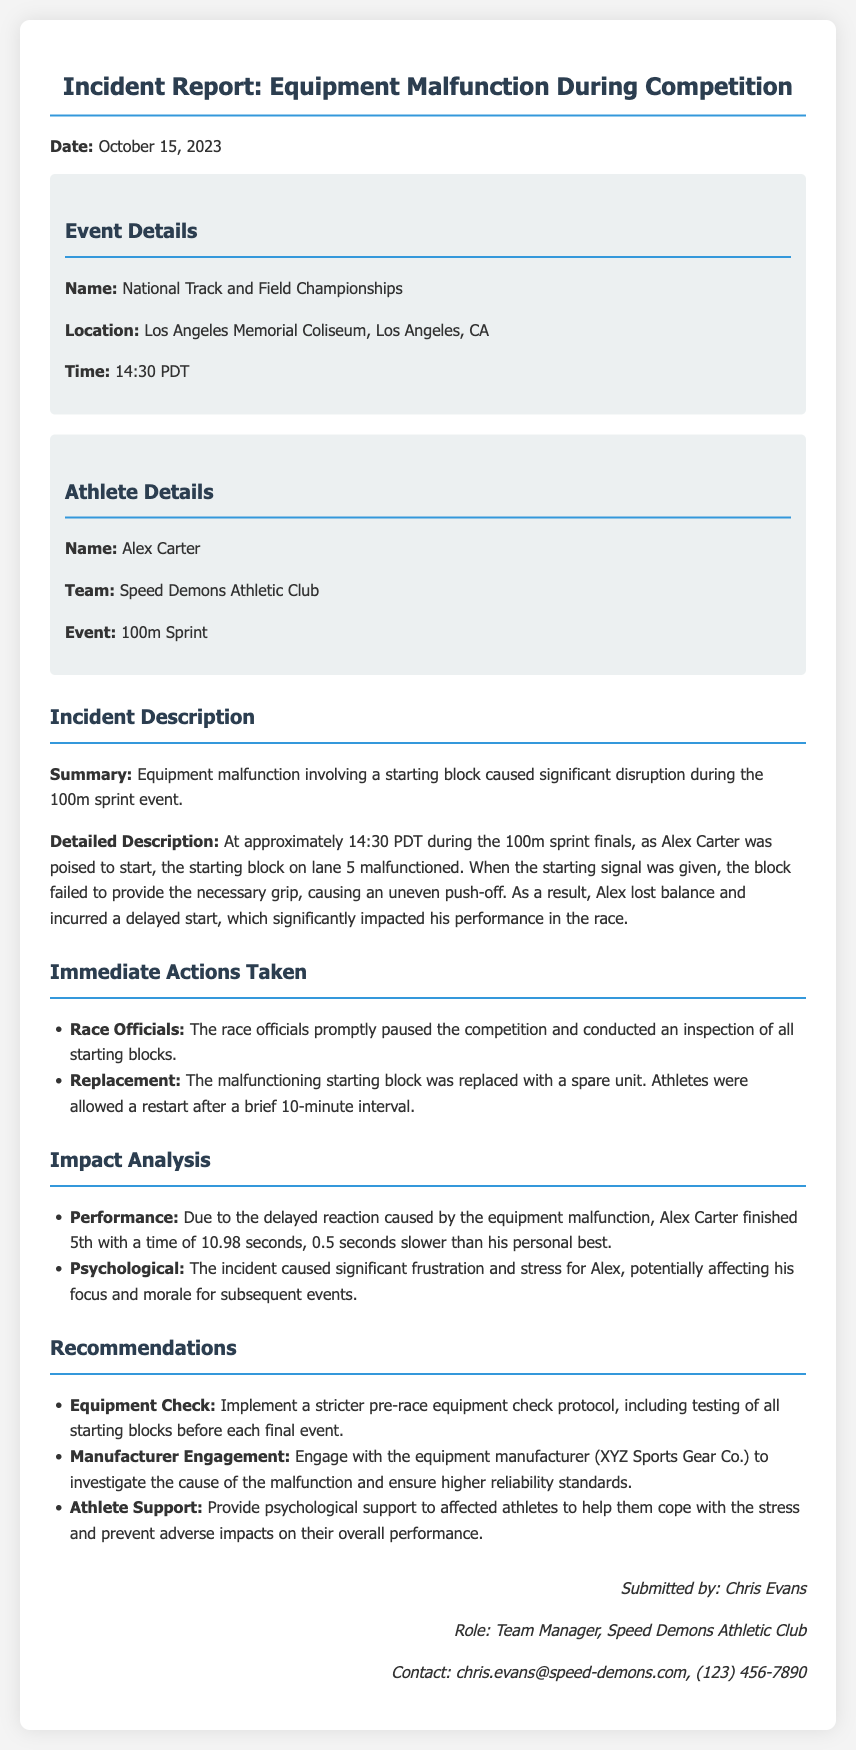What was the date of the incident? The date of the incident is stated at the beginning of the report, which is October 15, 2023.
Answer: October 15, 2023 Who was the athlete involved in the incident? The athlete's name is provided in the athlete details section of the report, which is Alex Carter.
Answer: Alex Carter What event was taking place when the malfunction occurred? The event name is mentioned in the event details section of the report, which is the National Track and Field Championships.
Answer: National Track and Field Championships What malfunction occurred during the competition? The type of malfunction is described in the incident description section, which was a starting block malfunction.
Answer: Starting block What was Alex Carter's finishing time? The athlete's finishing time is noted in the impact analysis section of the report, which is 10.98 seconds.
Answer: 10.98 seconds How long was the interval before the restart? The duration of the interval is specified in the immediate actions section, which is a brief 10-minute interval.
Answer: 10 minutes Which team did Alex Carter represent? The team name is mentioned in the athlete details section, which is Speed Demons Athletic Club.
Answer: Speed Demons Athletic Club What psychological effect did the incident have on Alex? The psychological impact is discussed in the impact analysis section, stating it caused significant frustration and stress.
Answer: Frustration and stress What recommendation was made regarding equipment checks? The recommendation for equipment checks is specifically stated in the recommendations section, which calls for a stricter pre-race equipment check protocol.
Answer: Stricter pre-race equipment check protocol 